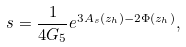Convert formula to latex. <formula><loc_0><loc_0><loc_500><loc_500>s = \frac { 1 } { 4 G _ { 5 } } e ^ { 3 A _ { s } ( z _ { h } ) - 2 \Phi ( z _ { h } ) } ,</formula> 